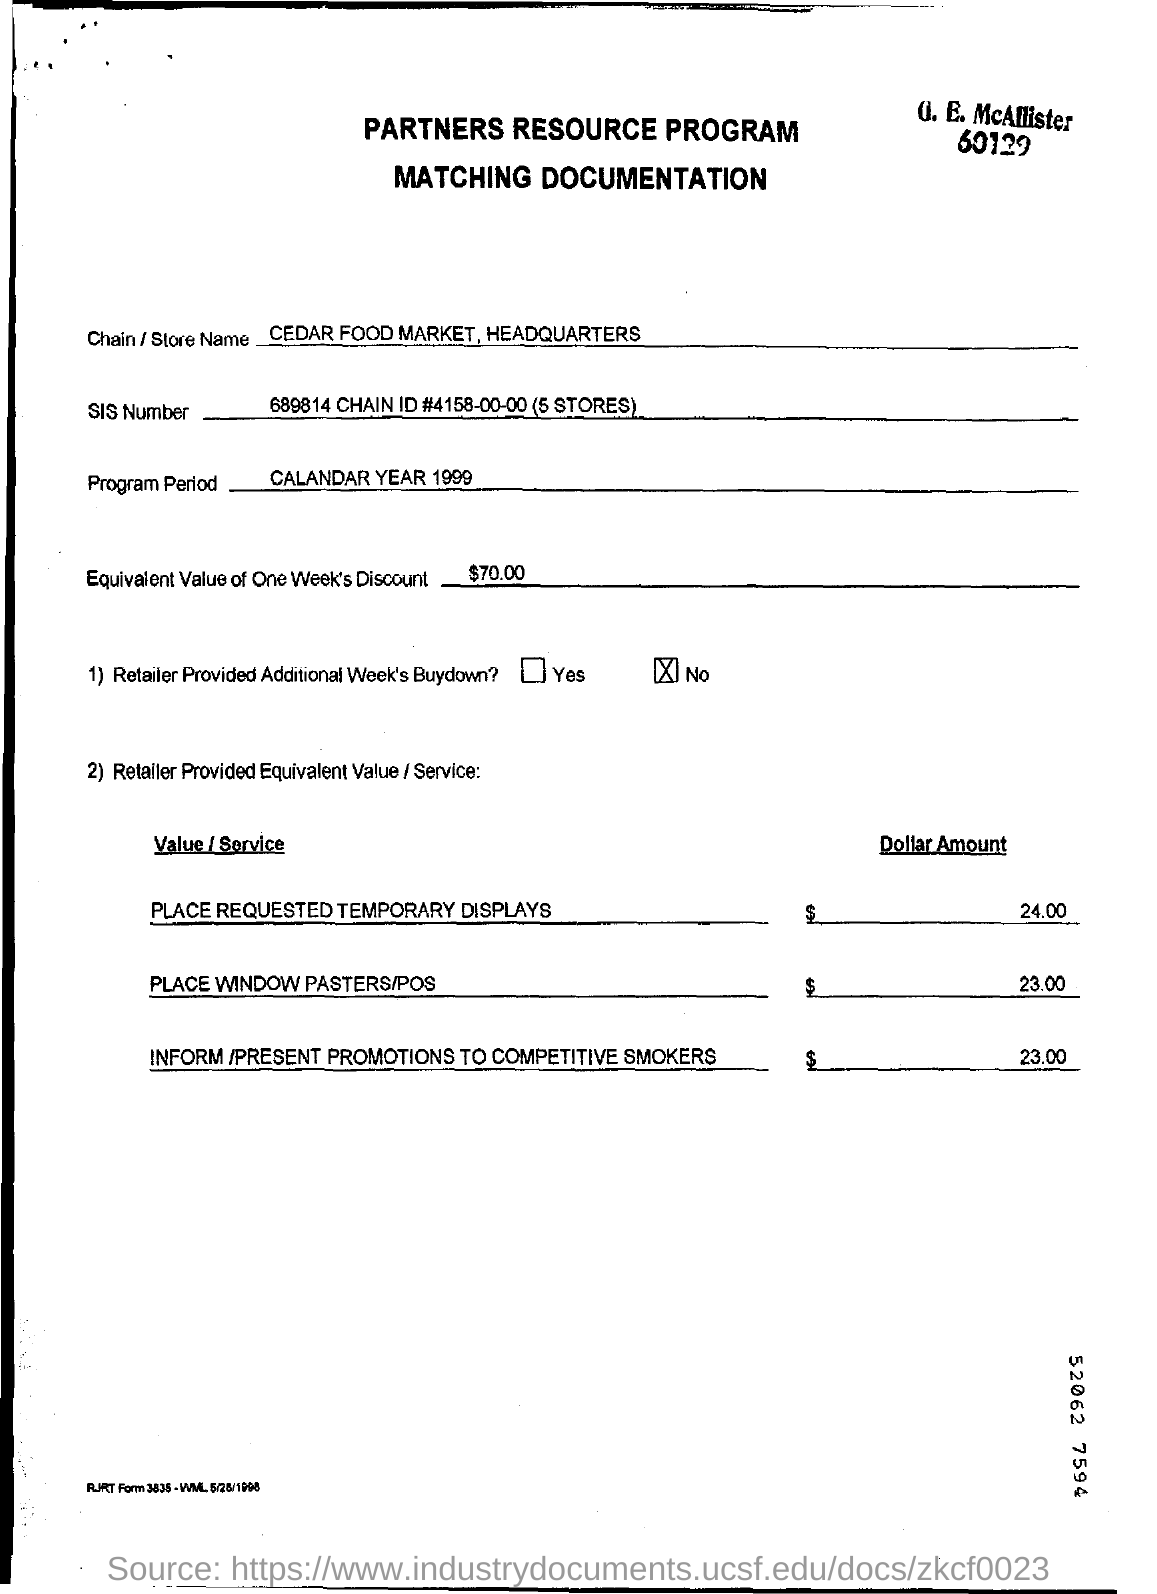Indicate a few pertinent items in this graphic. The equivalent value of one week's discount is $70.00. The SIS Number is 689814... The name of the store is Cedar Food Market, Headquarters. 